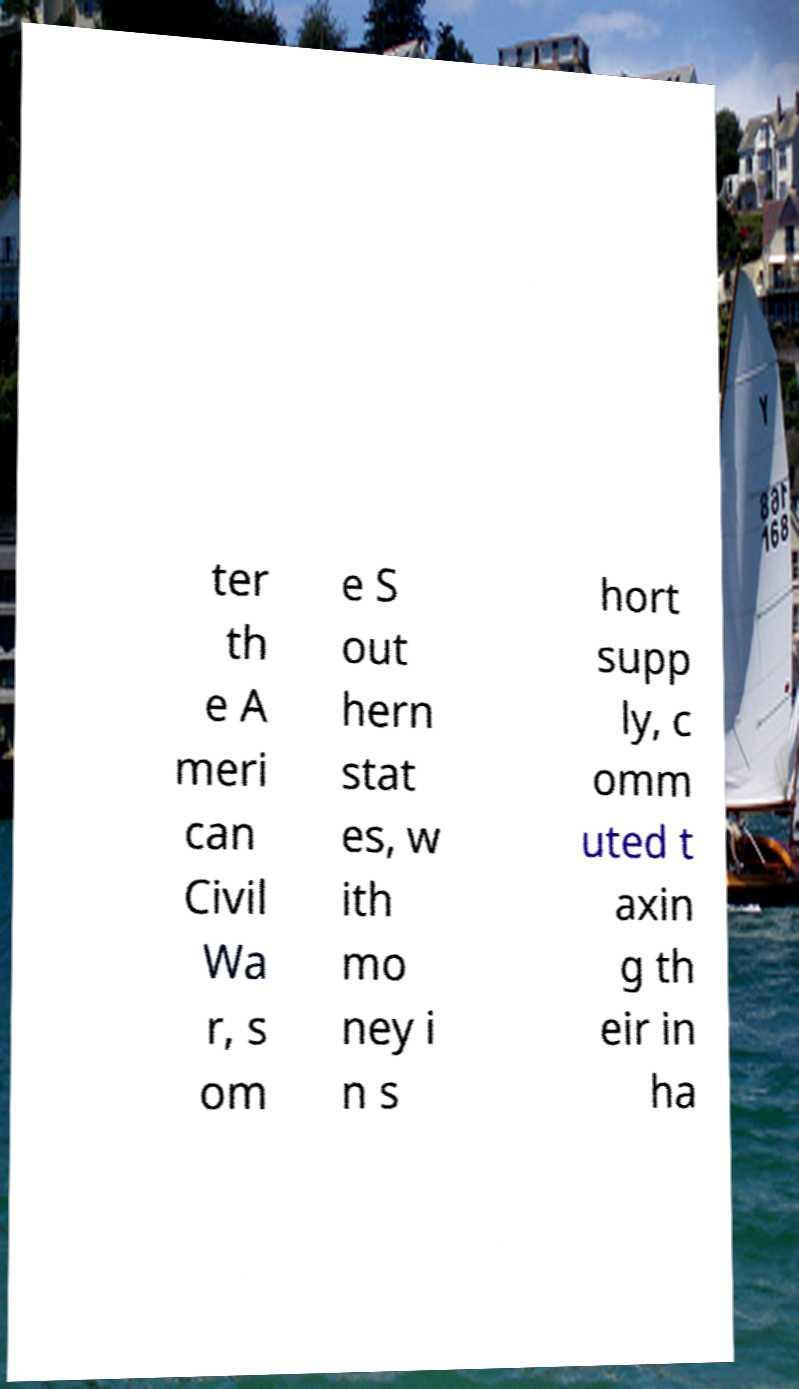Can you read and provide the text displayed in the image?This photo seems to have some interesting text. Can you extract and type it out for me? ter th e A meri can Civil Wa r, s om e S out hern stat es, w ith mo ney i n s hort supp ly, c omm uted t axin g th eir in ha 